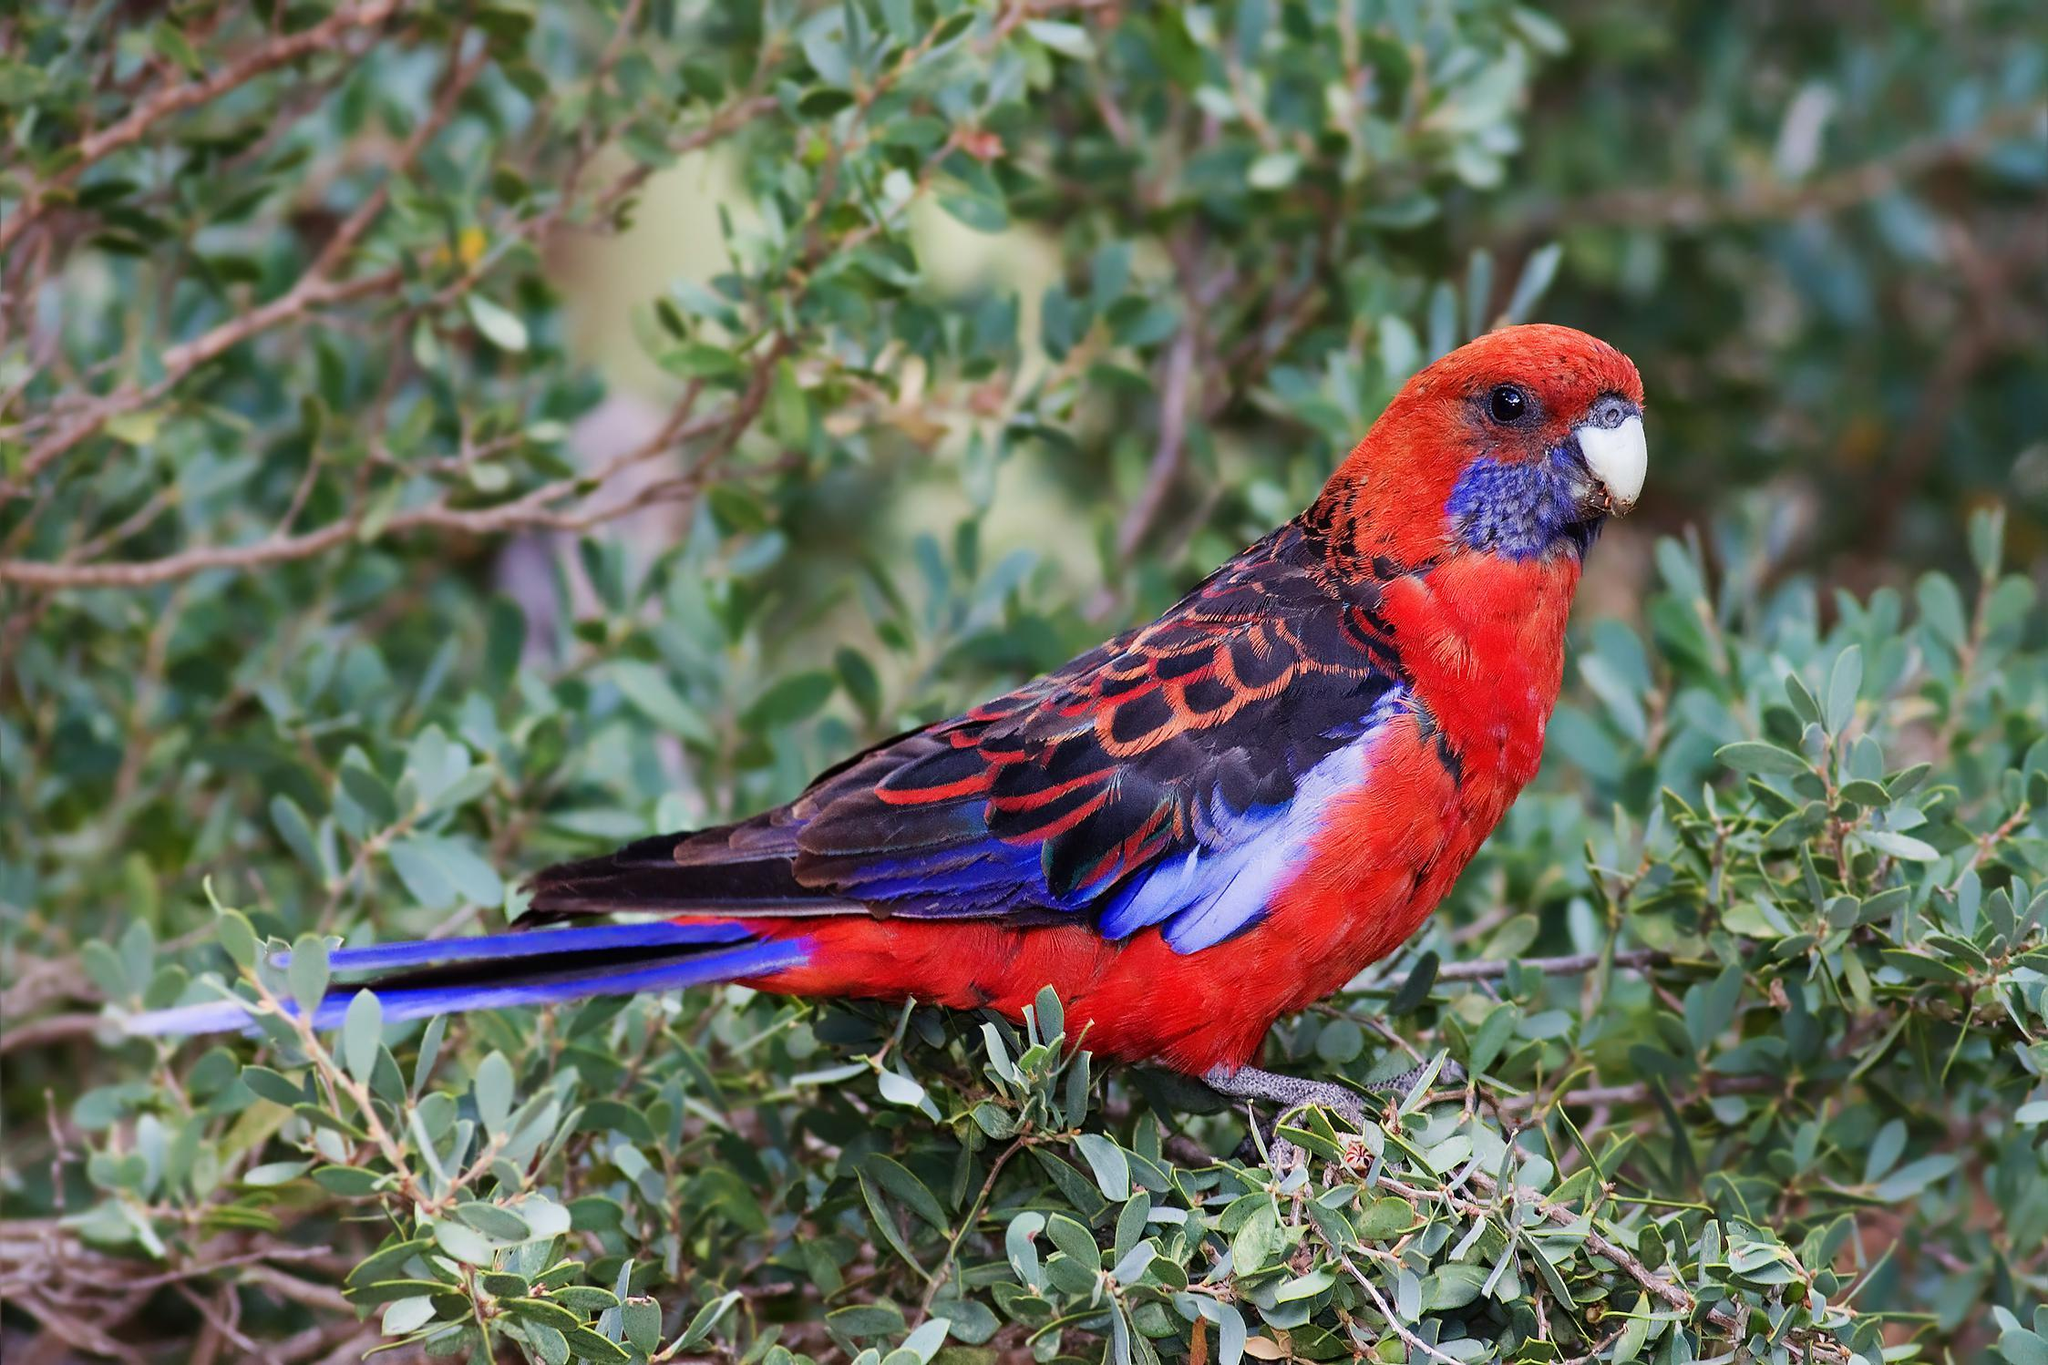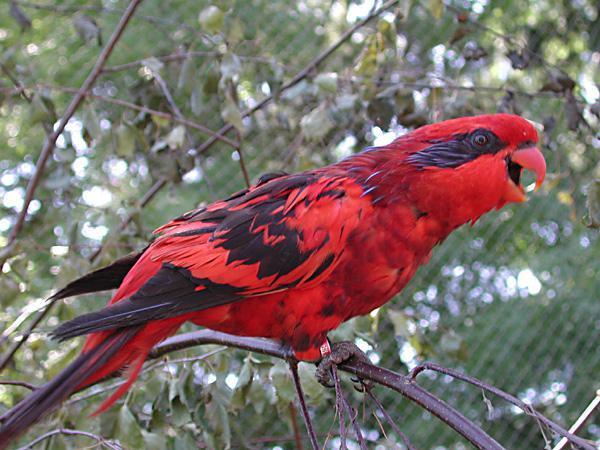The first image is the image on the left, the second image is the image on the right. Examine the images to the left and right. Is the description "The parrot furthest on the left is facing in the left direction." accurate? Answer yes or no. No. The first image is the image on the left, the second image is the image on the right. Assess this claim about the two images: "In one of the images, the birds are only shown as profile.". Correct or not? Answer yes or no. Yes. 